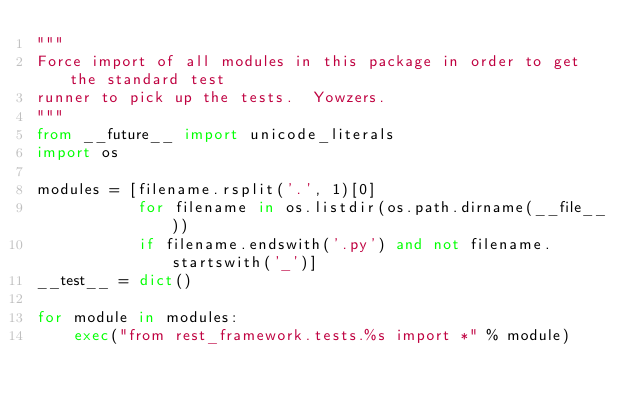Convert code to text. <code><loc_0><loc_0><loc_500><loc_500><_Python_>"""
Force import of all modules in this package in order to get the standard test
runner to pick up the tests.  Yowzers.
"""
from __future__ import unicode_literals
import os

modules = [filename.rsplit('.', 1)[0]
           for filename in os.listdir(os.path.dirname(__file__))
           if filename.endswith('.py') and not filename.startswith('_')]
__test__ = dict()

for module in modules:
    exec("from rest_framework.tests.%s import *" % module)
</code> 